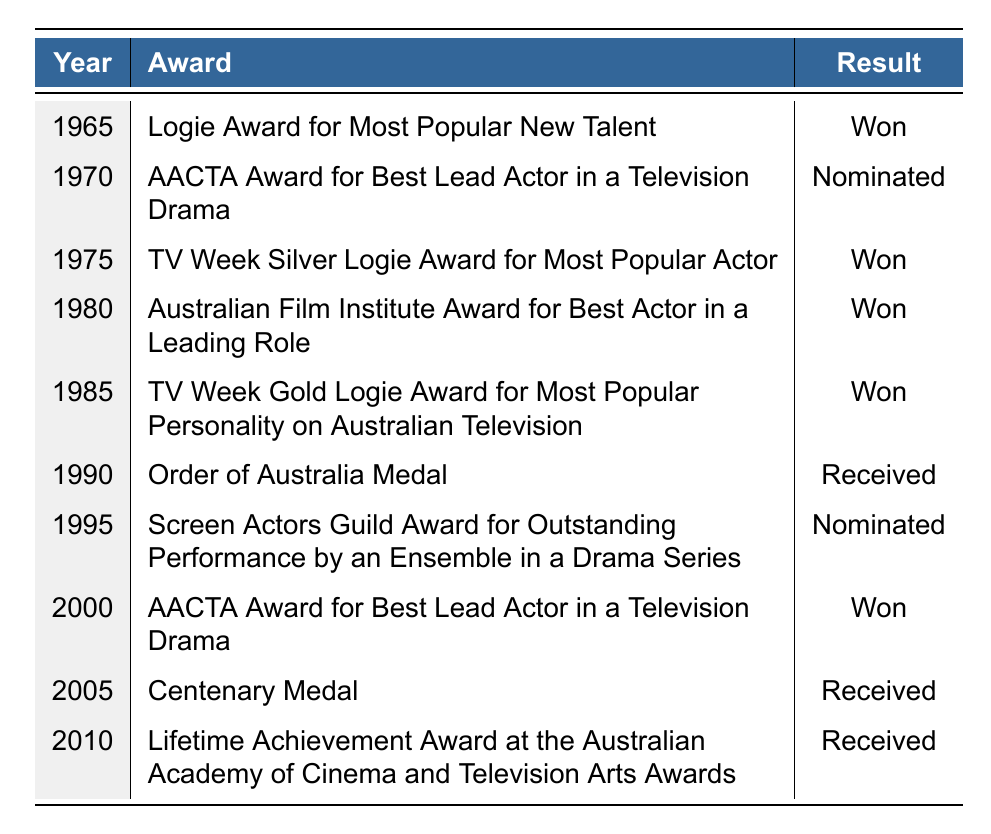What award did Cary Young win in 1965? In 1965, the table shows that Cary Young won the "Logie Award for Most Popular New Talent."
Answer: Logie Award for Most Popular New Talent How many awards did Cary Young win in total? By looking at the table, I can count the occurrences where the result is "Won." There are 5 such occurrences: in 1965, 1975, 1980, 1985, and 2000.
Answer: 5 Did Cary Young receive any nominations in the 1990s? In the table under the years 1990 and 1995, the results indicate that he received one nomination for the "Screen Actors Guild Award for Outstanding Performance by an Ensemble in a Drama Series" in 1995; thus, he did receive nominations in the 1990s.
Answer: Yes What was the result of Cary Young's nomination for the AACTA Award in 1970? By checking the 1970 entry, the table states that the result for the "AACTA Award for Best Lead Actor in a Television Drama" was "Nominated."
Answer: Nominated In which year did Cary Young receive the "Lifetime Achievement Award"? The table lists the "Lifetime Achievement Award at the Australian Academy of Cinema and Television Arts Awards" as received in 2010.
Answer: 2010 How many awards did Cary Young receive or achieve in total (considering won and received only)? The table shows that he won 5 awards and received 3 honors (Order of Australia Medal, Centenary Medal, and Lifetime Achievement Award). Thus, calculating these gives 5 + 3 = 8.
Answer: 8 Which award did Cary Young win last in the table? The last entry in the table is for the year 2010, where he received the "Lifetime Achievement Award," which indicates that this was the most recent award he won.
Answer: Lifetime Achievement Award Was there a year when Cary Young was nominated for more than one award? The table does not show any instance where Cary Young was nominated for more than one award in a single year; each year listed has either wins or a single nomination.
Answer: No What is the total number of awards and nominations Cary Young received from 1965 to 2010? Across the years provided in the table, Cary Young had 5 wins, was nominated twice, and received 3 honors. Adding these gives a total of 5 + 2 + 3 = 10.
Answer: 10 